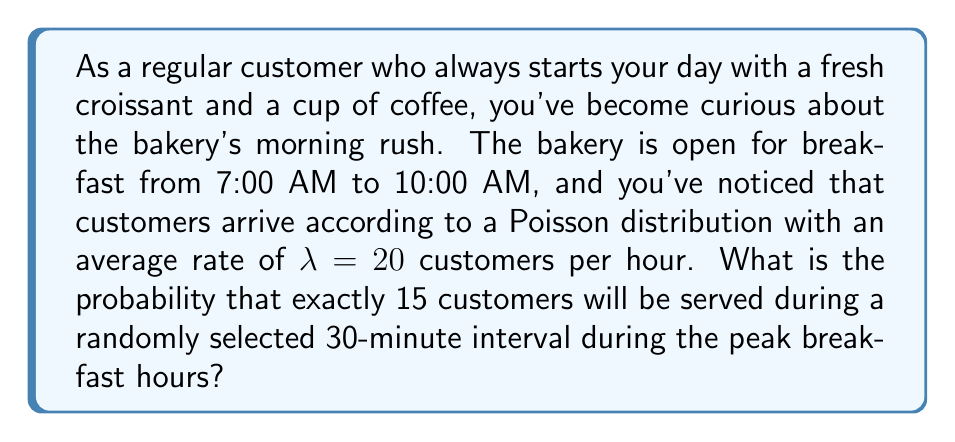What is the answer to this math problem? To solve this problem, we need to use the Poisson distribution formula. The Poisson distribution is used to model the number of events occurring in a fixed interval of time or space, given a known average rate.

The Poisson probability mass function is:

$$P(X = k) = \frac{e^{-\lambda} \lambda^k}{k!}$$

Where:
$\lambda$ is the average rate of events
$k$ is the number of events we're interested in
$e$ is Euler's number (approximately 2.71828)

Given:
- The average rate is 20 customers per hour
- We're interested in a 30-minute interval
- We want to know the probability of exactly 15 customers

Steps:
1. Adjust $\lambda$ for the 30-minute interval:
   $\lambda_{30min} = 20 \text{ customers/hour} \times \frac{1 \text{ hour}}{2} = 10 \text{ customers}$

2. Apply the Poisson formula:
   $$P(X = 15) = \frac{e^{-10} 10^{15}}{15!}$$

3. Calculate:
   $$P(X = 15) = \frac{2.71828^{-10} \times 10^{15}}{1307674368000}$$

4. Use a calculator to evaluate:
   $$P(X = 15) \approx 0.0347$$

Therefore, the probability of exactly 15 customers being served during a randomly selected 30-minute interval is approximately 0.0347 or 3.47%.
Answer: The probability is approximately 0.0347 or 3.47%. 